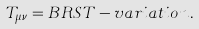<formula> <loc_0><loc_0><loc_500><loc_500>T _ { \mu \nu } = B R S T - v a r i a t i o n \, .</formula> 